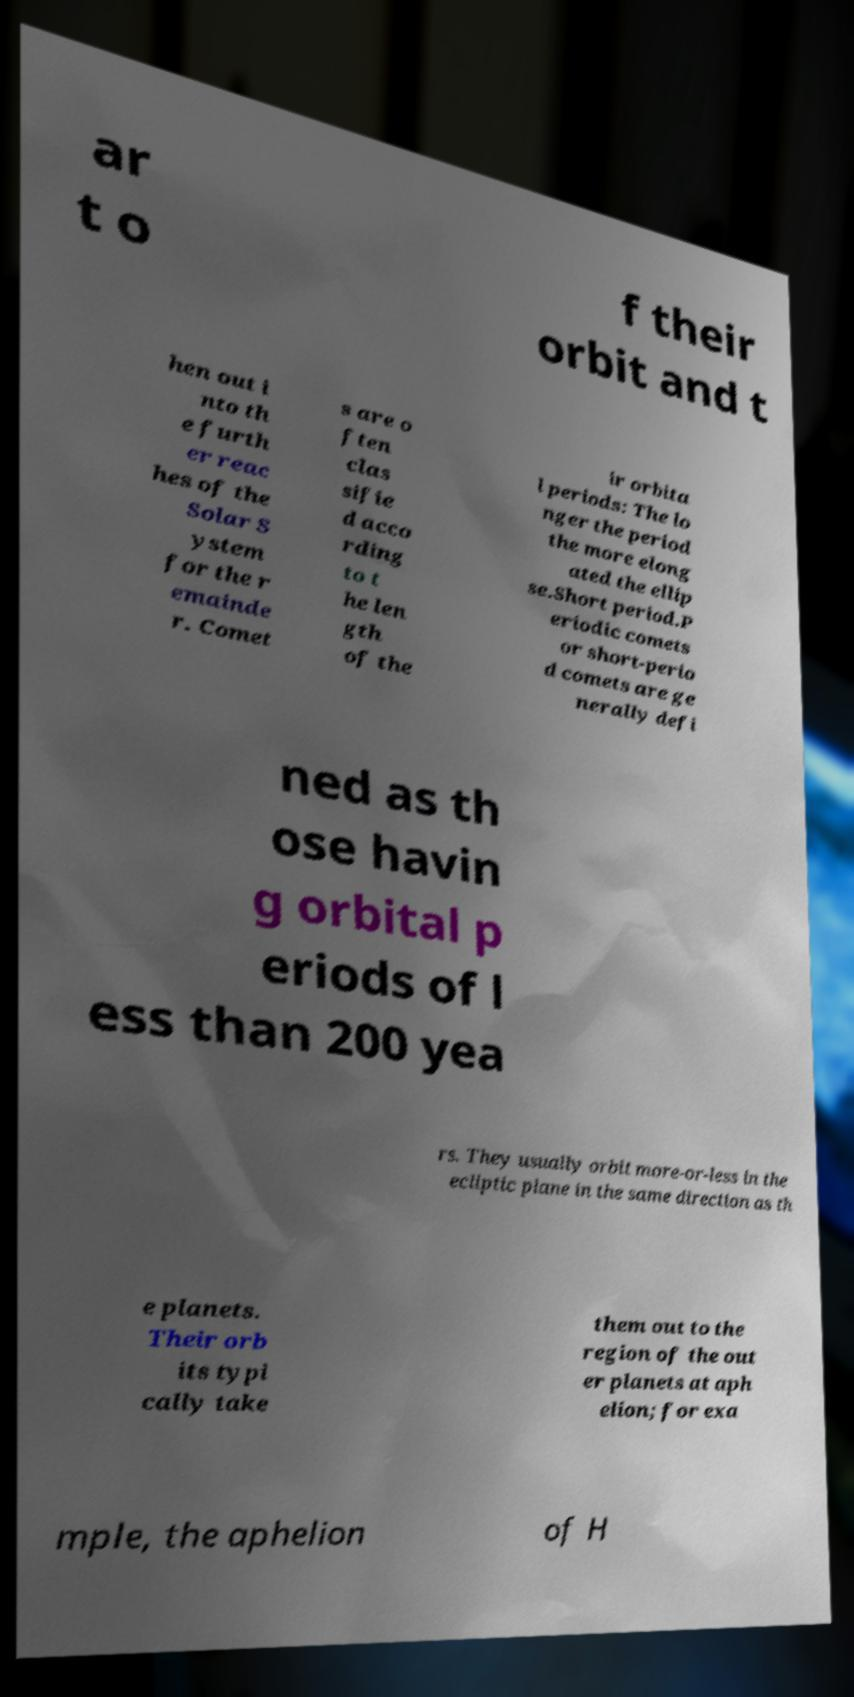I need the written content from this picture converted into text. Can you do that? ar t o f their orbit and t hen out i nto th e furth er reac hes of the Solar S ystem for the r emainde r. Comet s are o ften clas sifie d acco rding to t he len gth of the ir orbita l periods: The lo nger the period the more elong ated the ellip se.Short period.P eriodic comets or short-perio d comets are ge nerally defi ned as th ose havin g orbital p eriods of l ess than 200 yea rs. They usually orbit more-or-less in the ecliptic plane in the same direction as th e planets. Their orb its typi cally take them out to the region of the out er planets at aph elion; for exa mple, the aphelion of H 